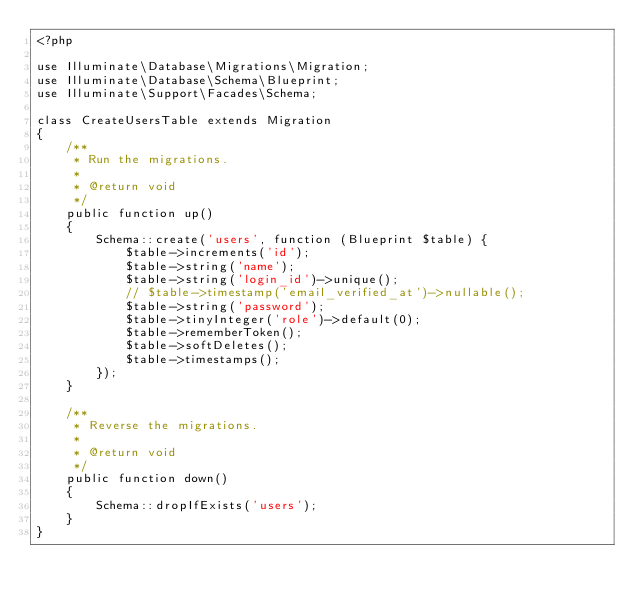Convert code to text. <code><loc_0><loc_0><loc_500><loc_500><_PHP_><?php

use Illuminate\Database\Migrations\Migration;
use Illuminate\Database\Schema\Blueprint;
use Illuminate\Support\Facades\Schema;

class CreateUsersTable extends Migration
{
    /**
     * Run the migrations.
     *
     * @return void
     */
    public function up()
    {
        Schema::create('users', function (Blueprint $table) {
            $table->increments('id');
            $table->string('name');
            $table->string('login_id')->unique();
            // $table->timestamp('email_verified_at')->nullable();
            $table->string('password');
            $table->tinyInteger('role')->default(0);
            $table->rememberToken();
            $table->softDeletes();
            $table->timestamps();
        });
    }

    /**
     * Reverse the migrations.
     *
     * @return void
     */
    public function down()
    {
        Schema::dropIfExists('users');
    }
}
</code> 